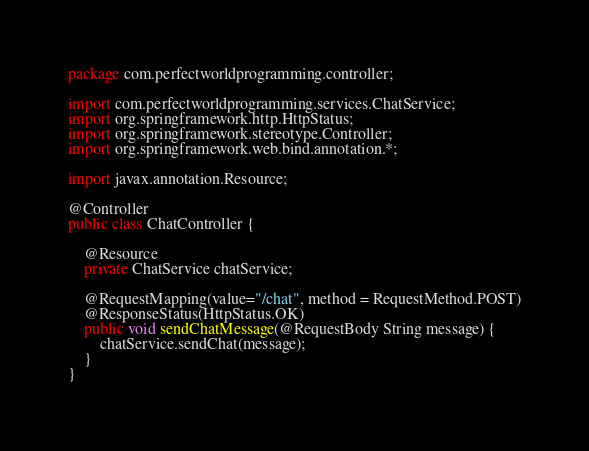<code> <loc_0><loc_0><loc_500><loc_500><_Java_>package com.perfectworldprogramming.controller;

import com.perfectworldprogramming.services.ChatService;
import org.springframework.http.HttpStatus;
import org.springframework.stereotype.Controller;
import org.springframework.web.bind.annotation.*;

import javax.annotation.Resource;

@Controller
public class ChatController {

    @Resource
    private ChatService chatService;

    @RequestMapping(value="/chat", method = RequestMethod.POST)
    @ResponseStatus(HttpStatus.OK)
    public void sendChatMessage(@RequestBody String message) {
        chatService.sendChat(message);
    }
}
</code> 